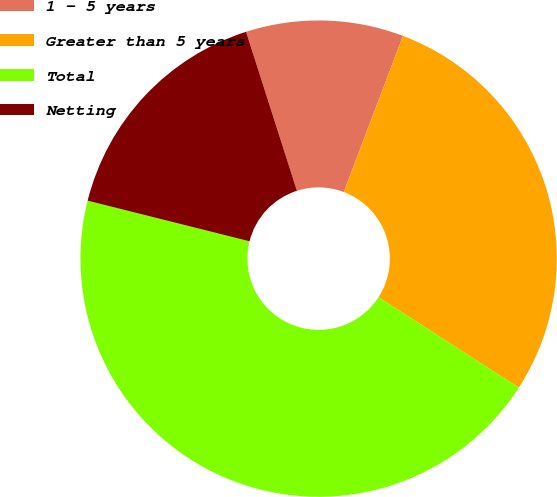Convert chart to OTSL. <chart><loc_0><loc_0><loc_500><loc_500><pie_chart><fcel>1 - 5 years<fcel>Greater than 5 years<fcel>Total<fcel>Netting<nl><fcel>10.69%<fcel>28.35%<fcel>44.8%<fcel>16.16%<nl></chart> 